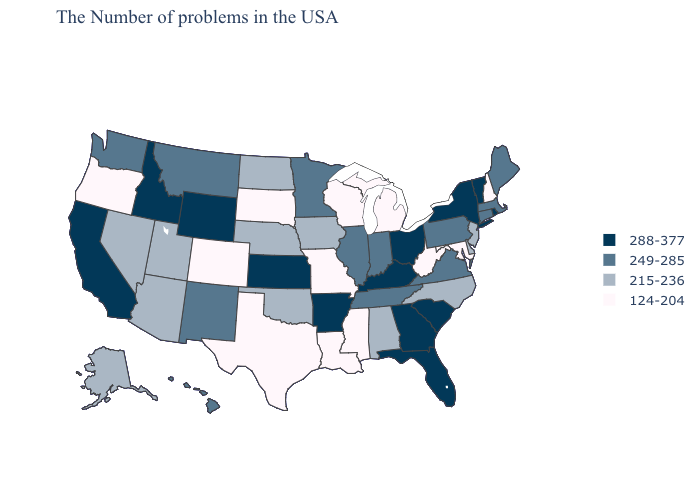Does the first symbol in the legend represent the smallest category?
Be succinct. No. Name the states that have a value in the range 215-236?
Answer briefly. New Jersey, Delaware, North Carolina, Alabama, Iowa, Nebraska, Oklahoma, North Dakota, Utah, Arizona, Nevada, Alaska. Does Idaho have a lower value than Connecticut?
Quick response, please. No. Among the states that border Iowa , does Illinois have the highest value?
Write a very short answer. Yes. Name the states that have a value in the range 215-236?
Be succinct. New Jersey, Delaware, North Carolina, Alabama, Iowa, Nebraska, Oklahoma, North Dakota, Utah, Arizona, Nevada, Alaska. Among the states that border Nebraska , which have the highest value?
Write a very short answer. Kansas, Wyoming. What is the value of Pennsylvania?
Give a very brief answer. 249-285. Which states have the highest value in the USA?
Keep it brief. Rhode Island, Vermont, New York, South Carolina, Ohio, Florida, Georgia, Kentucky, Arkansas, Kansas, Wyoming, Idaho, California. What is the lowest value in states that border Tennessee?
Write a very short answer. 124-204. Which states hav the highest value in the West?
Answer briefly. Wyoming, Idaho, California. Which states have the highest value in the USA?
Concise answer only. Rhode Island, Vermont, New York, South Carolina, Ohio, Florida, Georgia, Kentucky, Arkansas, Kansas, Wyoming, Idaho, California. Among the states that border Georgia , which have the lowest value?
Quick response, please. North Carolina, Alabama. Name the states that have a value in the range 249-285?
Keep it brief. Maine, Massachusetts, Connecticut, Pennsylvania, Virginia, Indiana, Tennessee, Illinois, Minnesota, New Mexico, Montana, Washington, Hawaii. Name the states that have a value in the range 124-204?
Short answer required. New Hampshire, Maryland, West Virginia, Michigan, Wisconsin, Mississippi, Louisiana, Missouri, Texas, South Dakota, Colorado, Oregon. Which states have the lowest value in the West?
Be succinct. Colorado, Oregon. 